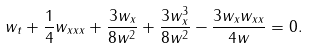<formula> <loc_0><loc_0><loc_500><loc_500>w _ { t } + \frac { 1 } { 4 } w _ { x x x } + \frac { 3 w _ { x } } { 8 w ^ { 2 } } + \frac { 3 w _ { x } ^ { 3 } } { 8 w ^ { 2 } } - \frac { 3 w _ { x } w _ { x x } } { 4 w } = 0 .</formula> 